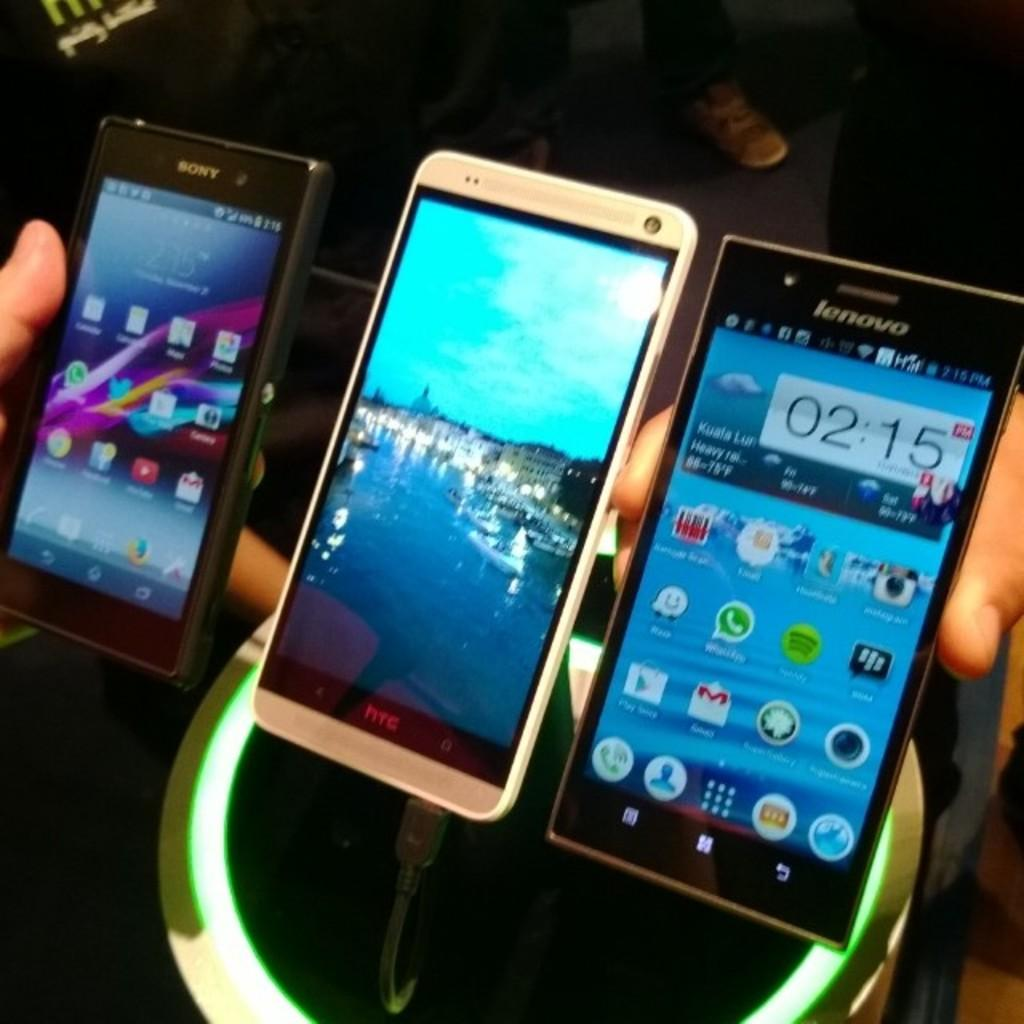<image>
Write a terse but informative summary of the picture. Three smart phones in a row, the rightmost one is a Lenovo brand. 